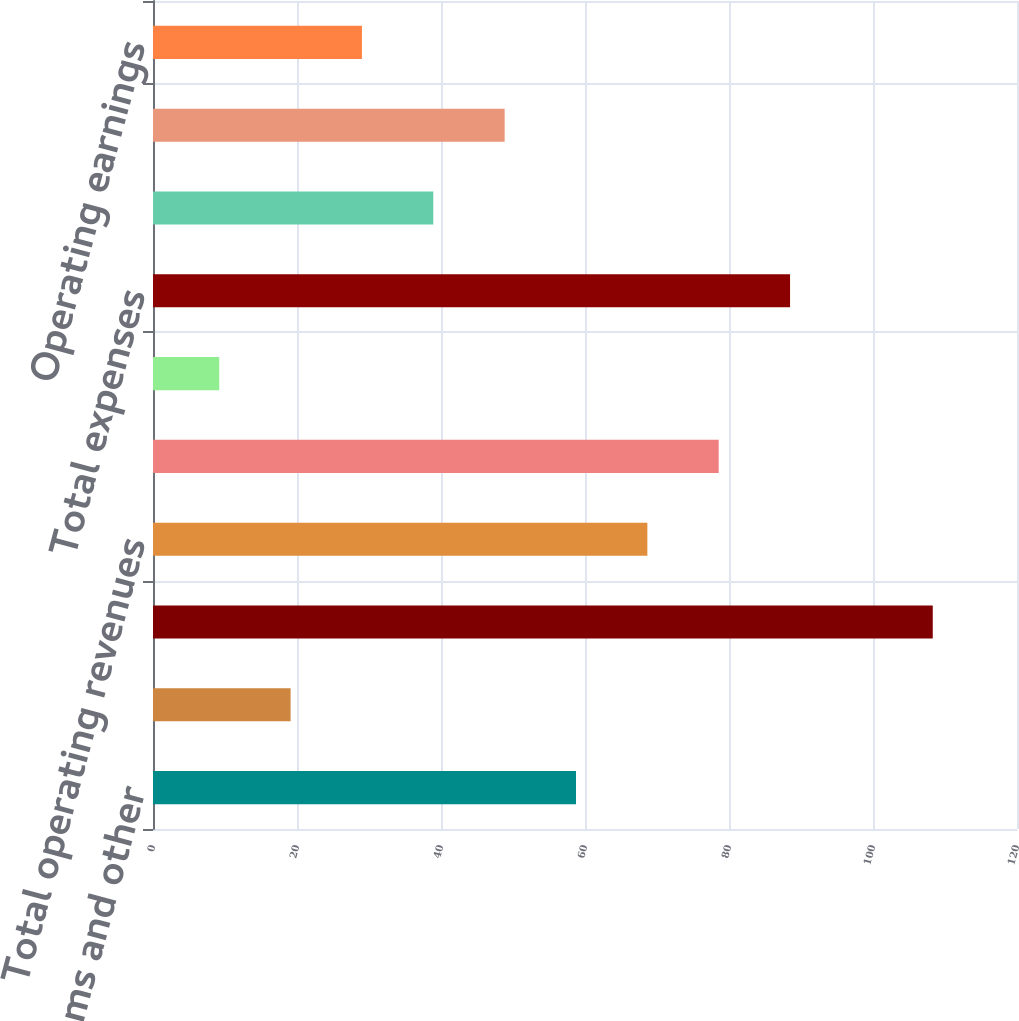Convert chart. <chart><loc_0><loc_0><loc_500><loc_500><bar_chart><fcel>Premiums and other<fcel>Fees and other revenues<fcel>Net investment income<fcel>Total operating revenues<fcel>Benefits claims and settlement<fcel>Operating expenses<fcel>Total expenses<fcel>Operating earnings before<fcel>Income taxes (benefits)<fcel>Operating earnings<nl><fcel>58.75<fcel>19.11<fcel>108.3<fcel>68.66<fcel>78.57<fcel>9.2<fcel>88.48<fcel>38.93<fcel>48.84<fcel>29.02<nl></chart> 